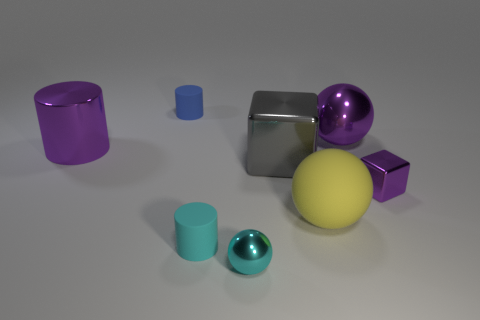Add 2 cyan matte cylinders. How many objects exist? 10 Subtract all balls. How many objects are left? 5 Add 6 purple metal cylinders. How many purple metal cylinders are left? 7 Add 3 big yellow things. How many big yellow things exist? 4 Subtract 0 yellow cylinders. How many objects are left? 8 Subtract all small yellow cylinders. Subtract all small purple objects. How many objects are left? 7 